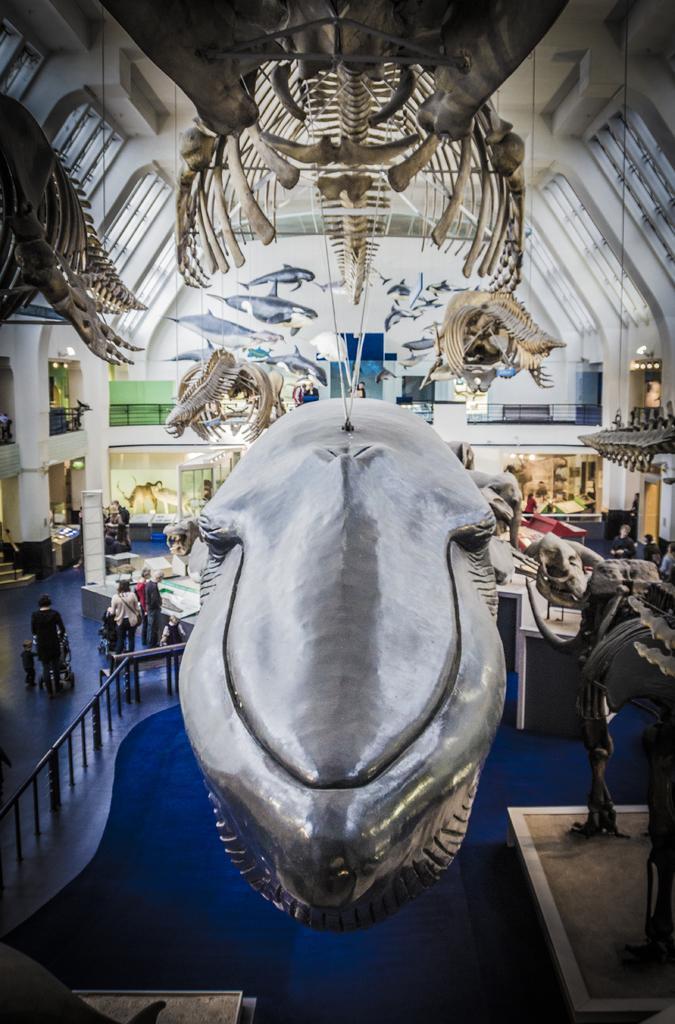How would you summarize this image in a sentence or two? In the picture we can see inside view of the museum with a skeleton of the dinosaurs and on the floor, we can see some people are standing watching something which are kept in the glasses. 